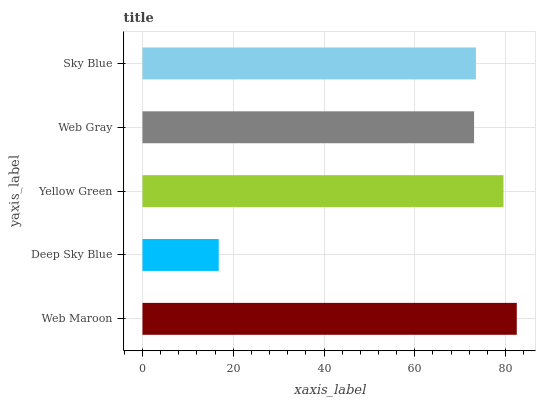Is Deep Sky Blue the minimum?
Answer yes or no. Yes. Is Web Maroon the maximum?
Answer yes or no. Yes. Is Yellow Green the minimum?
Answer yes or no. No. Is Yellow Green the maximum?
Answer yes or no. No. Is Yellow Green greater than Deep Sky Blue?
Answer yes or no. Yes. Is Deep Sky Blue less than Yellow Green?
Answer yes or no. Yes. Is Deep Sky Blue greater than Yellow Green?
Answer yes or no. No. Is Yellow Green less than Deep Sky Blue?
Answer yes or no. No. Is Sky Blue the high median?
Answer yes or no. Yes. Is Sky Blue the low median?
Answer yes or no. Yes. Is Web Maroon the high median?
Answer yes or no. No. Is Web Maroon the low median?
Answer yes or no. No. 